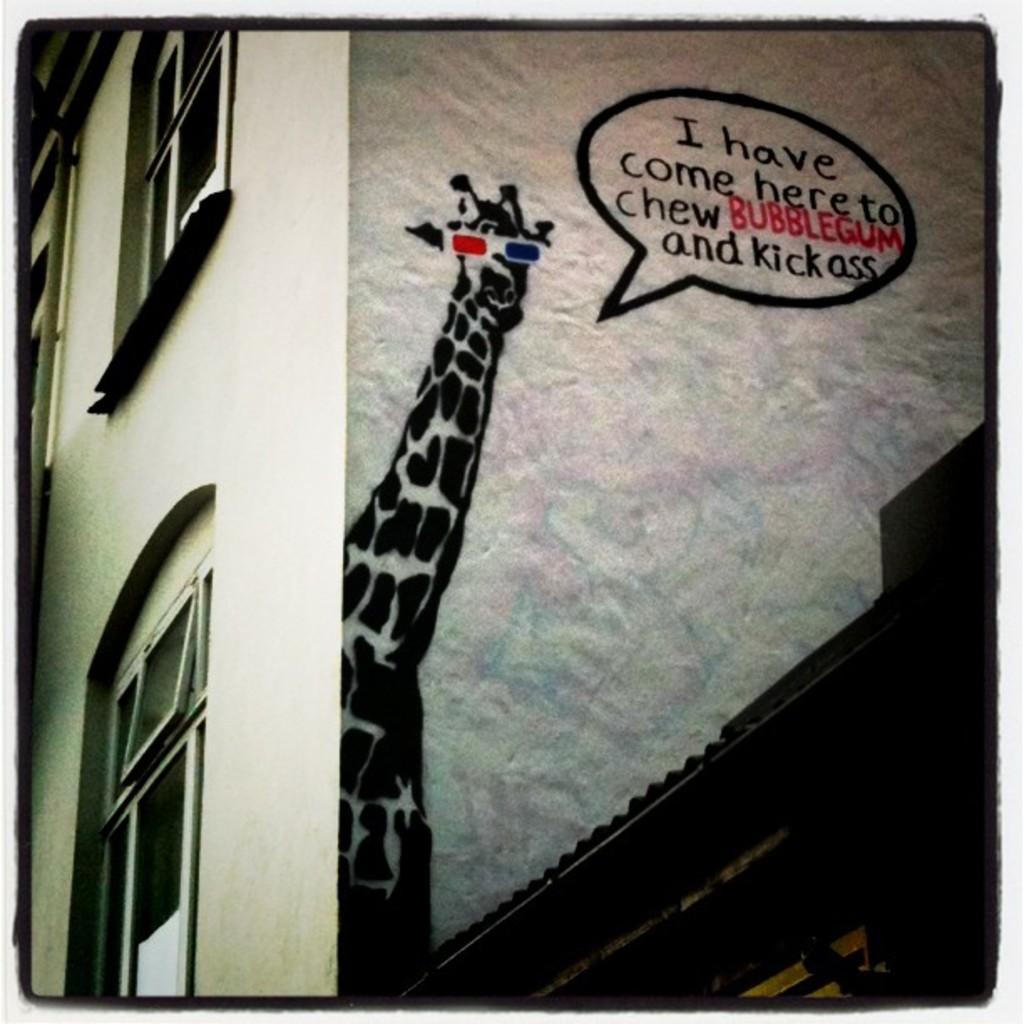In one or two sentences, can you explain what this image depicts? In this image we can see a building with windows. On the wall there is a drawing of a giraffe. Also something is written. 